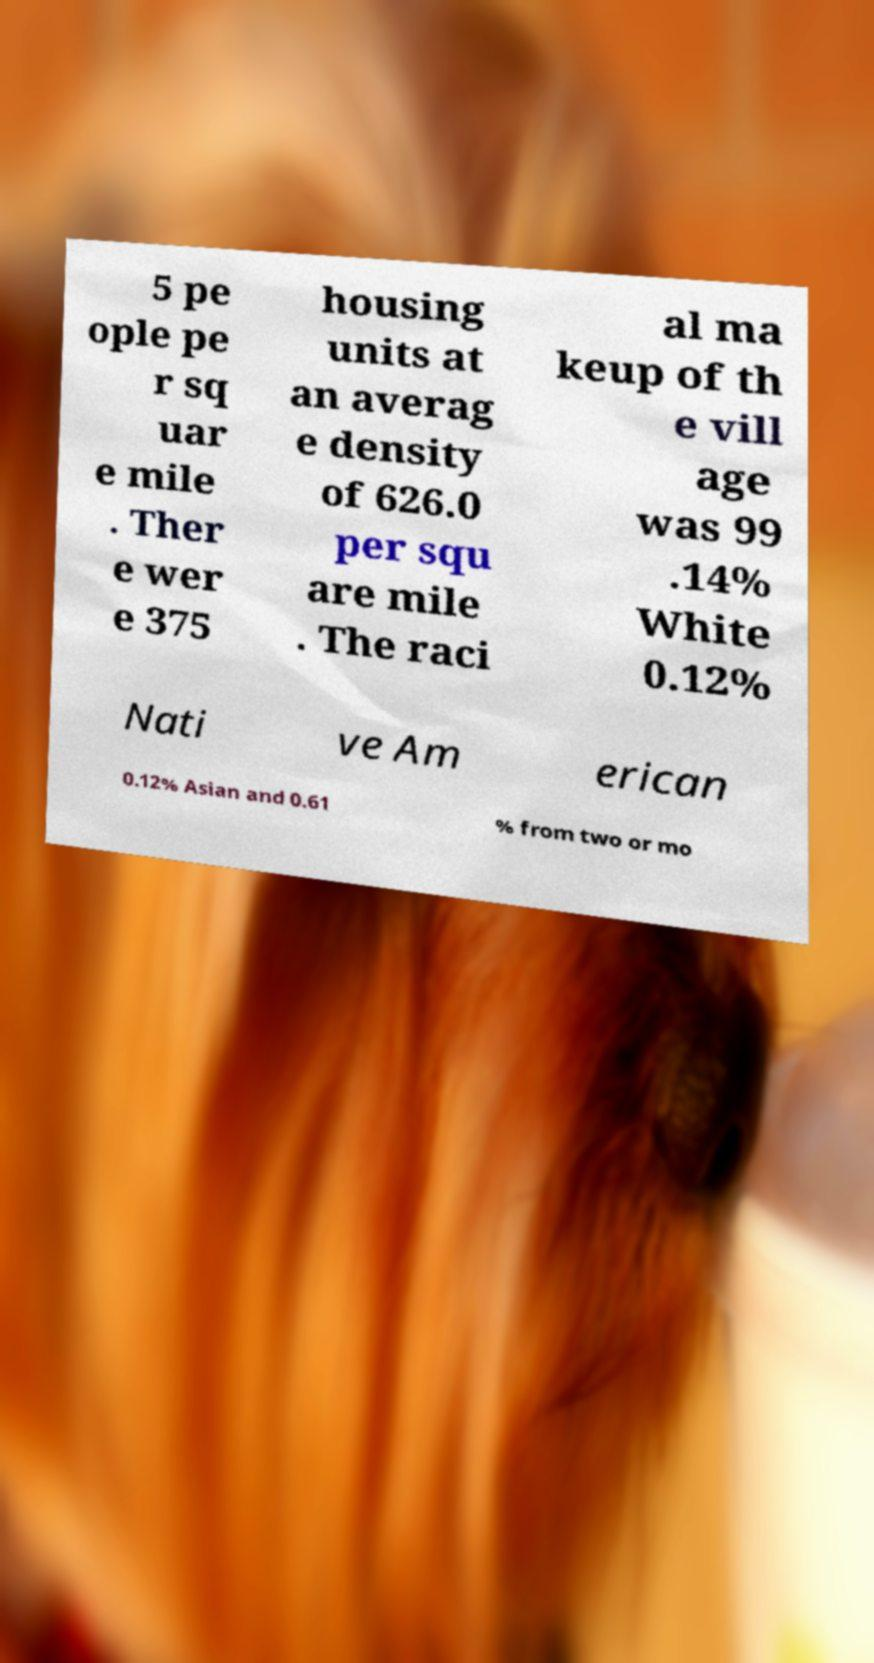Could you extract and type out the text from this image? 5 pe ople pe r sq uar e mile . Ther e wer e 375 housing units at an averag e density of 626.0 per squ are mile . The raci al ma keup of th e vill age was 99 .14% White 0.12% Nati ve Am erican 0.12% Asian and 0.61 % from two or mo 